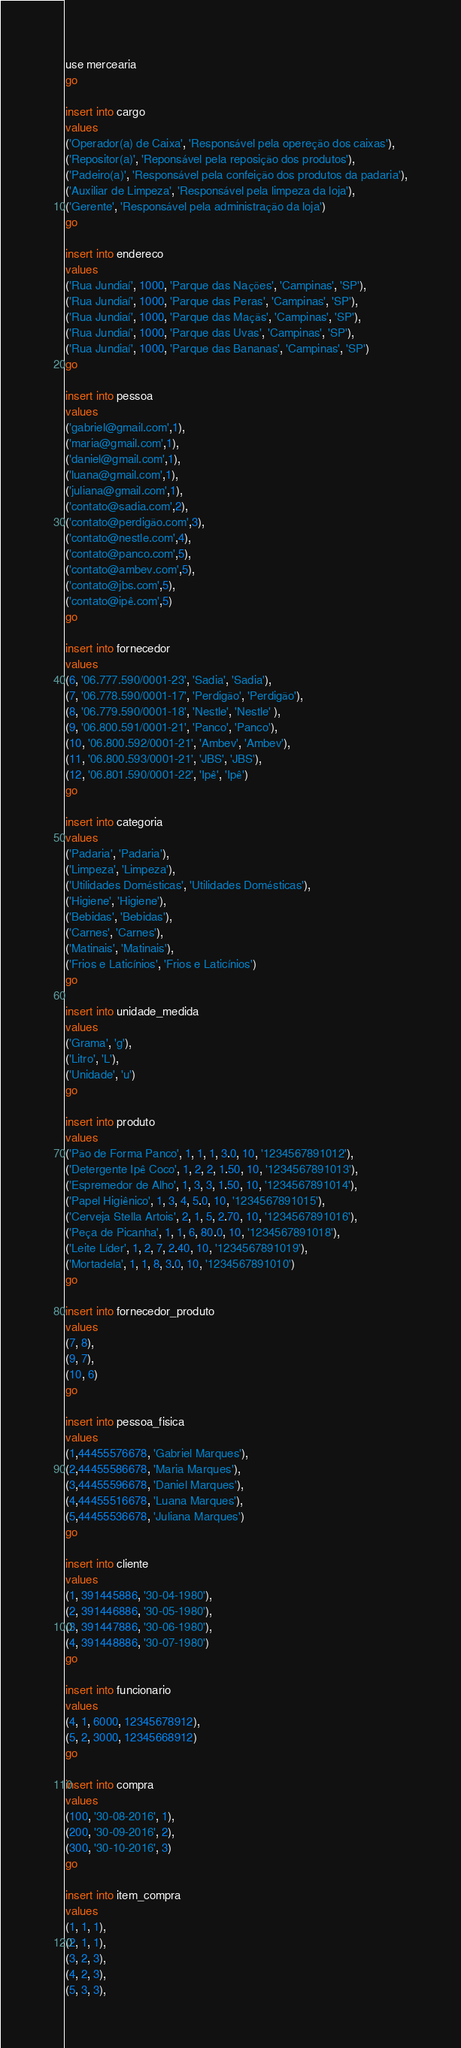<code> <loc_0><loc_0><loc_500><loc_500><_SQL_>use mercearia
go

insert into cargo
values 
('Operador(a) de Caixa', 'Responsável pela opereção dos caixas'),
('Repositor(a)', 'Reponsável pela reposição dos produtos'),
('Padeiro(a)', 'Responsável pela confeição dos produtos da padaria'),
('Auxiliar de Limpeza', 'Responsável pela limpeza da loja'),
('Gerente', 'Responsável pela administração da loja')
go

insert into endereco
values
('Rua Jundiaí', 1000, 'Parque das Nações', 'Campinas', 'SP'),
('Rua Jundiaí', 1000, 'Parque das Peras', 'Campinas', 'SP'),
('Rua Jundiaí', 1000, 'Parque das Maçãs', 'Campinas', 'SP'),
('Rua Jundiaí', 1000, 'Parque das Uvas', 'Campinas', 'SP'),
('Rua Jundiaí', 1000, 'Parque das Bananas', 'Campinas', 'SP')
go

insert into pessoa
values
('gabriel@gmail.com',1),
('maria@gmail.com',1),
('daniel@gmail.com',1),
('luana@gmail.com',1),
('juliana@gmail.com',1),
('contato@sadia.com',2),
('contato@perdigão.com',3),
('contato@nestle.com',4),
('contato@panco.com',5),
('contato@ambev.com',5),
('contato@jbs.com',5),
('contato@ipê.com',5)
go

insert into fornecedor
values
(6, '06.777.590/0001-23', 'Sadia', 'Sadia'),
(7, '06.778.590/0001-17', 'Perdigão', 'Perdigão'),
(8, '06.779.590/0001-18', 'Nestle', 'Nestle' ),
(9, '06.800.591/0001-21', 'Panco', 'Panco'),
(10, '06.800.592/0001-21', 'Ambev', 'Ambev'),
(11, '06.800.593/0001-21', 'JBS', 'JBS'),
(12, '06.801.590/0001-22', 'Ipê', 'Ipê')
go

insert into categoria
values
('Padaria', 'Padaria'),
('Limpeza', 'Limpeza'),
('Utilidades Domésticas', 'Utilidades Domésticas'),
('Higiene', 'Higiene'),
('Bebidas', 'Bebidas'),
('Carnes', 'Carnes'),
('Matinais', 'Matinais'),
('Frios e Laticínios', 'Frios e Laticínios')
go

insert into unidade_medida
values
('Grama', 'g'),
('Litro', 'L'),
('Unidade', 'u')
go

insert into produto
values
('Pão de Forma Panco', 1, 1, 1, 3.0, 10, '1234567891012'),
('Detergente Ipê Coco', 1, 2, 2, 1.50, 10, '1234567891013'),
('Espremedor de Alho', 1, 3, 3, 1.50, 10, '1234567891014'),
('Papel Higiênico', 1, 3, 4, 5.0, 10, '1234567891015'),
('Cerveja Stella Artois', 2, 1, 5, 2.70, 10, '1234567891016'),
('Peça de Picanha', 1, 1, 6, 80.0, 10, '1234567891018'),
('Leite Líder', 1, 2, 7, 2.40, 10, '1234567891019'),
('Mortadela', 1, 1, 8, 3.0, 10, '1234567891010')
go

insert into fornecedor_produto
values
(7, 8),
(9, 7),
(10, 6)
go

insert into pessoa_fisica
values
(1,44455576678, 'Gabriel Marques'),
(2,44455586678, 'Maria Marques'),
(3,44455596678, 'Daniel Marques'),
(4,44455516678, 'Luana Marques'),
(5,44455536678, 'Juliana Marques')
go

insert into cliente
values
(1, 391445886, '30-04-1980'),
(2, 391446886, '30-05-1980'),
(3, 391447886, '30-06-1980'),
(4, 391448886, '30-07-1980')
go

insert into funcionario
values
(4, 1, 6000, 12345678912),
(5, 2, 3000, 12345668912)
go

insert into compra
values
(100, '30-08-2016', 1),
(200, '30-09-2016', 2),
(300, '30-10-2016', 3)
go

insert into item_compra
values
(1, 1, 1),
(2, 1, 1),
(3, 2, 3),
(4, 2, 3),
(5, 3, 3),</code> 